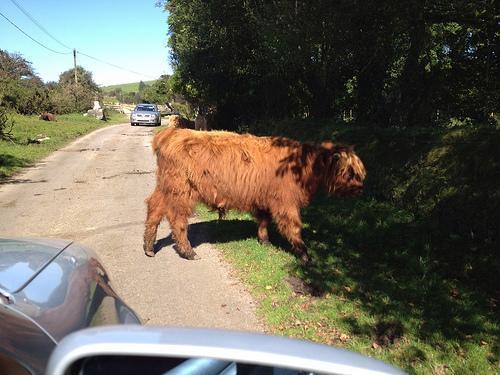How many cows are there?
Give a very brief answer. 1. How many legs does the cow have?
Give a very brief answer. 4. 